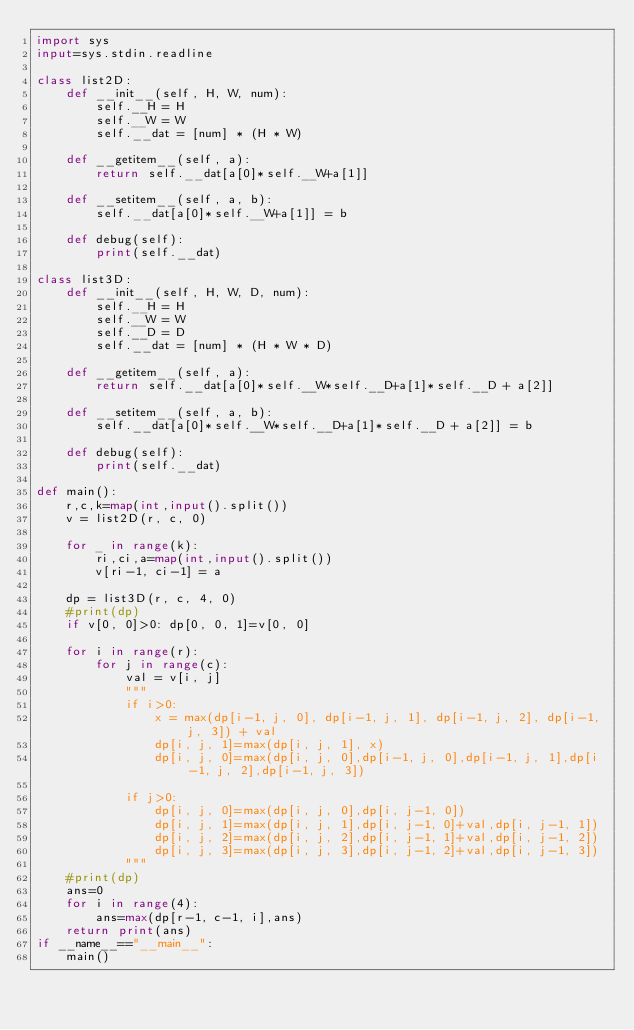<code> <loc_0><loc_0><loc_500><loc_500><_Python_>import sys
input=sys.stdin.readline

class list2D:
    def __init__(self, H, W, num):
        self.__H = H
        self.__W = W
        self.__dat = [num] * (H * W)

    def __getitem__(self, a):
        return self.__dat[a[0]*self.__W+a[1]]

    def __setitem__(self, a, b):
        self.__dat[a[0]*self.__W+a[1]] = b

    def debug(self):
        print(self.__dat)

class list3D:
    def __init__(self, H, W, D, num):
        self.__H = H
        self.__W = W
        self.__D = D
        self.__dat = [num] * (H * W * D)

    def __getitem__(self, a):
        return self.__dat[a[0]*self.__W*self.__D+a[1]*self.__D + a[2]]

    def __setitem__(self, a, b):
        self.__dat[a[0]*self.__W*self.__D+a[1]*self.__D + a[2]] = b

    def debug(self):
        print(self.__dat)

def main():
    r,c,k=map(int,input().split())
    v = list2D(r, c, 0)

    for _ in range(k):
        ri,ci,a=map(int,input().split())
        v[ri-1, ci-1] = a

    dp = list3D(r, c, 4, 0)
    #print(dp)
    if v[0, 0]>0: dp[0, 0, 1]=v[0, 0]

    for i in range(r):
        for j in range(c):
            val = v[i, j]
            """
            if i>0:
                x = max(dp[i-1, j, 0], dp[i-1, j, 1], dp[i-1, j, 2], dp[i-1, j, 3]) + val
                dp[i, j, 1]=max(dp[i, j, 1], x)
                dp[i, j, 0]=max(dp[i, j, 0],dp[i-1, j, 0],dp[i-1, j, 1],dp[i-1, j, 2],dp[i-1, j, 3])

            if j>0:
                dp[i, j, 0]=max(dp[i, j, 0],dp[i, j-1, 0])
                dp[i, j, 1]=max(dp[i, j, 1],dp[i, j-1, 0]+val,dp[i, j-1, 1])
                dp[i, j, 2]=max(dp[i, j, 2],dp[i, j-1, 1]+val,dp[i, j-1, 2])
                dp[i, j, 3]=max(dp[i, j, 3],dp[i, j-1, 2]+val,dp[i, j-1, 3])
            """
    #print(dp)
    ans=0
    for i in range(4):
        ans=max(dp[r-1, c-1, i],ans)
    return print(ans)
if __name__=="__main__":
    main()
</code> 